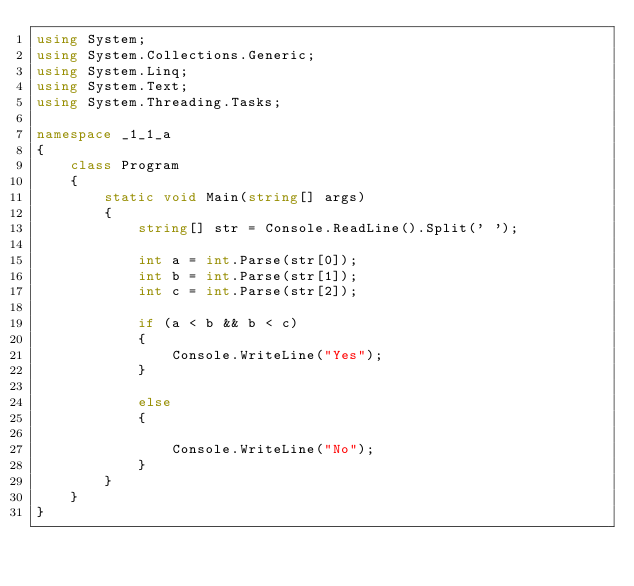Convert code to text. <code><loc_0><loc_0><loc_500><loc_500><_C#_>using System;
using System.Collections.Generic;
using System.Linq;
using System.Text;
using System.Threading.Tasks;

namespace _1_1_a
{
    class Program
    {
        static void Main(string[] args)
        {
            string[] str = Console.ReadLine().Split(' ');

            int a = int.Parse(str[0]);
            int b = int.Parse(str[1]);
            int c = int.Parse(str[2]);

            if (a < b && b < c)
            {
                Console.WriteLine("Yes");
            }

            else
            { 
            
                Console.WriteLine("No");
            }  
        }
    }
}

</code> 